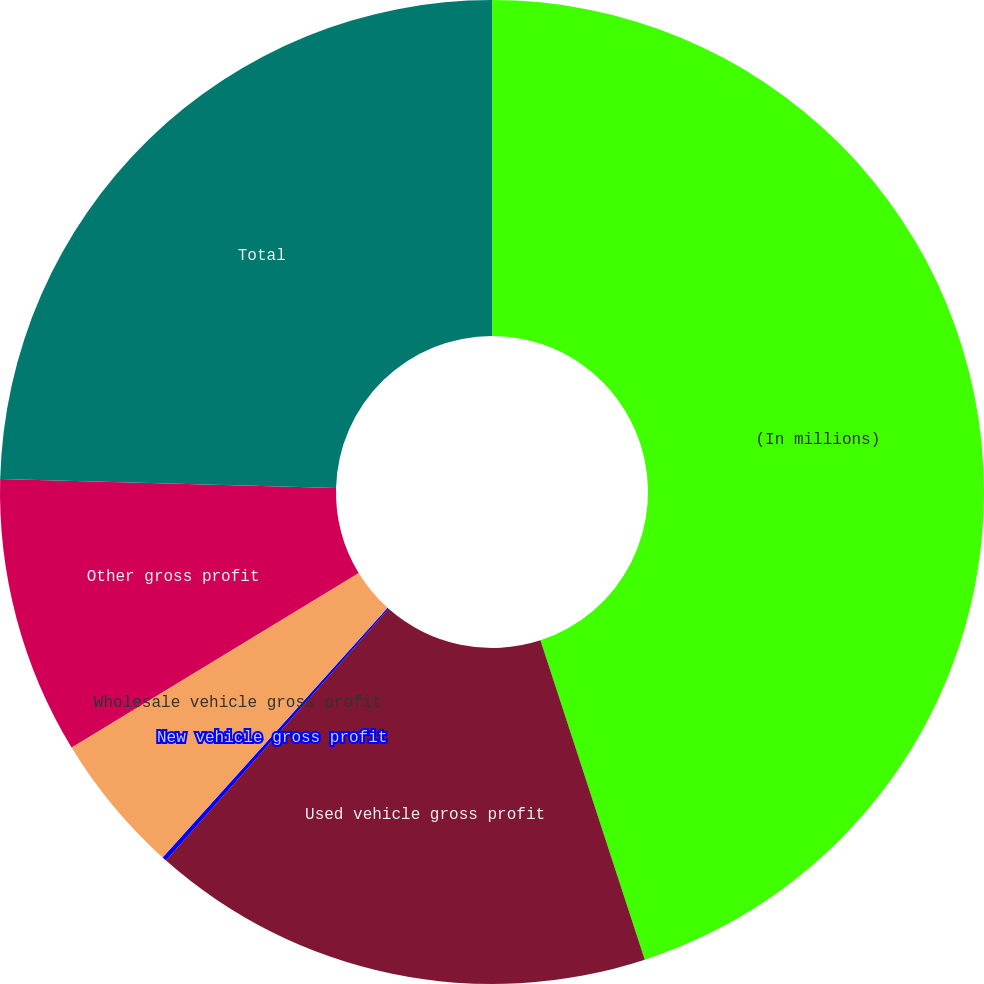Convert chart. <chart><loc_0><loc_0><loc_500><loc_500><pie_chart><fcel>(In millions)<fcel>Used vehicle gross profit<fcel>New vehicle gross profit<fcel>Wholesale vehicle gross profit<fcel>Other gross profit<fcel>Total<nl><fcel>44.97%<fcel>16.55%<fcel>0.15%<fcel>4.63%<fcel>9.11%<fcel>24.58%<nl></chart> 